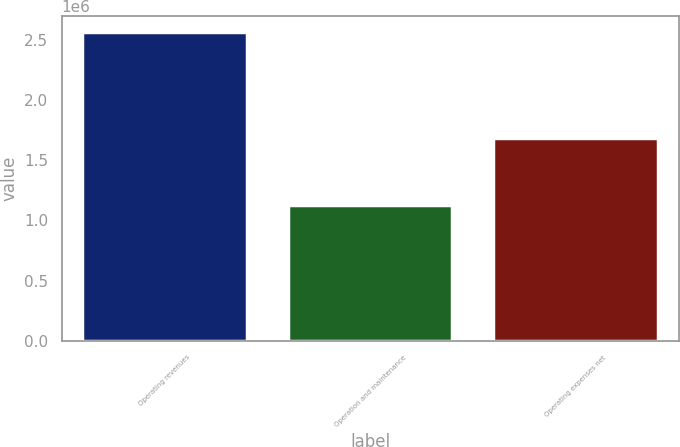<chart> <loc_0><loc_0><loc_500><loc_500><bar_chart><fcel>Operating revenues<fcel>Operation and maintenance<fcel>Operating expenses net<nl><fcel>2.56443e+06<fcel>1.12999e+06<fcel>1.68573e+06<nl></chart> 